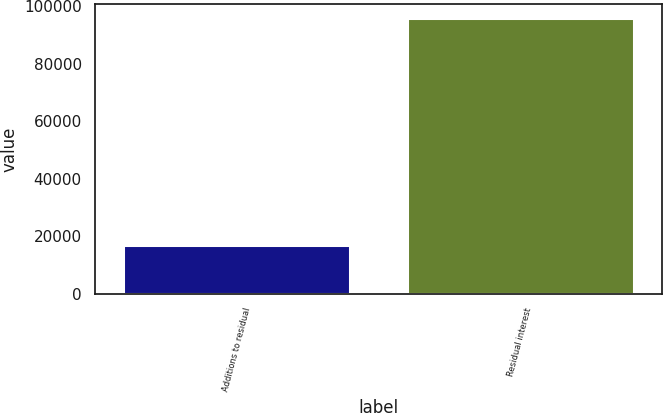Convert chart to OTSL. <chart><loc_0><loc_0><loc_500><loc_500><bar_chart><fcel>Additions to residual<fcel>Residual interest<nl><fcel>16914<fcel>95929<nl></chart> 